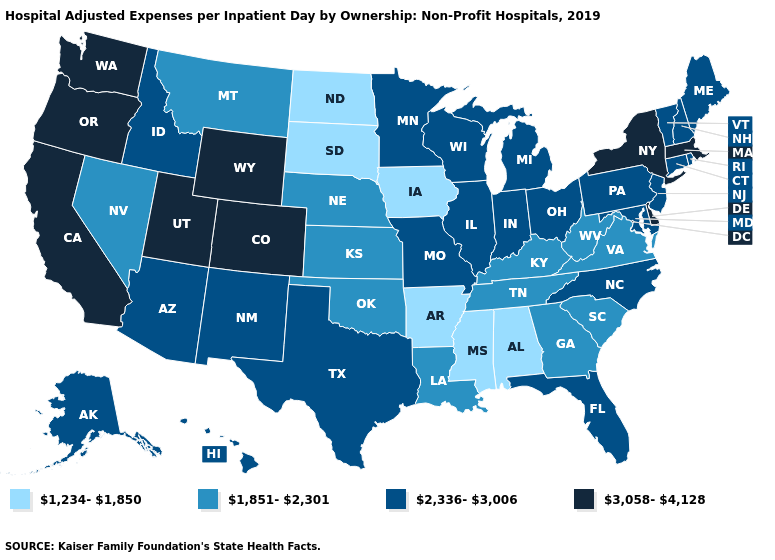Among the states that border Utah , which have the highest value?
Short answer required. Colorado, Wyoming. What is the value of California?
Write a very short answer. 3,058-4,128. Which states have the highest value in the USA?
Concise answer only. California, Colorado, Delaware, Massachusetts, New York, Oregon, Utah, Washington, Wyoming. Which states have the highest value in the USA?
Concise answer only. California, Colorado, Delaware, Massachusetts, New York, Oregon, Utah, Washington, Wyoming. Name the states that have a value in the range 2,336-3,006?
Give a very brief answer. Alaska, Arizona, Connecticut, Florida, Hawaii, Idaho, Illinois, Indiana, Maine, Maryland, Michigan, Minnesota, Missouri, New Hampshire, New Jersey, New Mexico, North Carolina, Ohio, Pennsylvania, Rhode Island, Texas, Vermont, Wisconsin. Does Rhode Island have a lower value than Nebraska?
Concise answer only. No. Name the states that have a value in the range 1,851-2,301?
Give a very brief answer. Georgia, Kansas, Kentucky, Louisiana, Montana, Nebraska, Nevada, Oklahoma, South Carolina, Tennessee, Virginia, West Virginia. Among the states that border Wisconsin , which have the lowest value?
Be succinct. Iowa. Name the states that have a value in the range 3,058-4,128?
Quick response, please. California, Colorado, Delaware, Massachusetts, New York, Oregon, Utah, Washington, Wyoming. What is the highest value in the South ?
Short answer required. 3,058-4,128. Does the map have missing data?
Give a very brief answer. No. What is the highest value in the USA?
Quick response, please. 3,058-4,128. Name the states that have a value in the range 1,234-1,850?
Be succinct. Alabama, Arkansas, Iowa, Mississippi, North Dakota, South Dakota. What is the value of Ohio?
Write a very short answer. 2,336-3,006. 